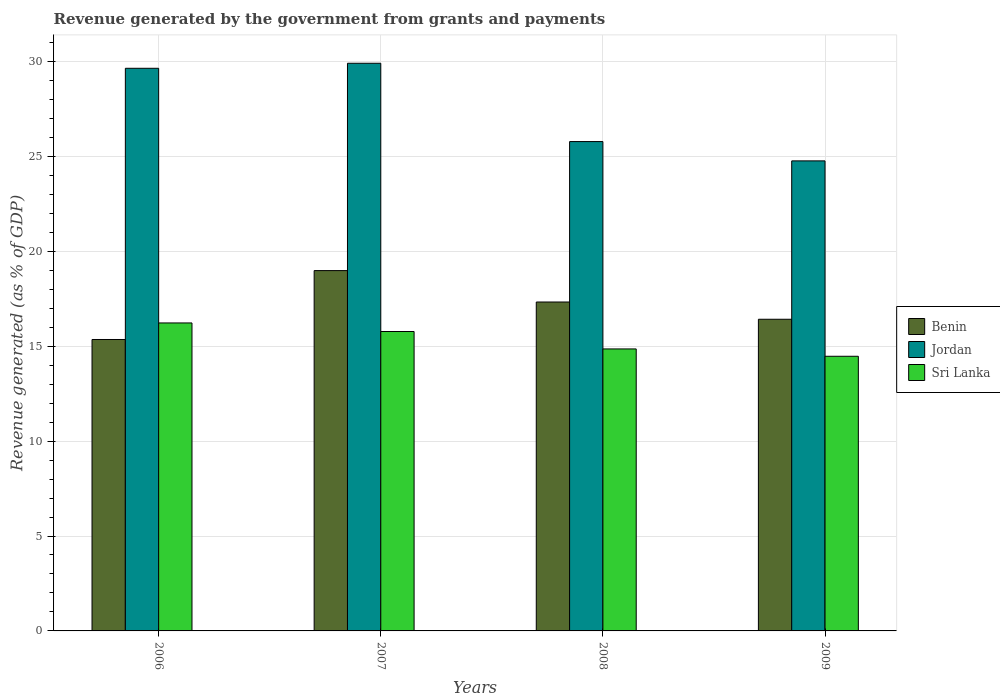Are the number of bars per tick equal to the number of legend labels?
Offer a very short reply. Yes. How many bars are there on the 1st tick from the left?
Give a very brief answer. 3. How many bars are there on the 4th tick from the right?
Your response must be concise. 3. What is the revenue generated by the government in Benin in 2006?
Make the answer very short. 15.35. Across all years, what is the maximum revenue generated by the government in Jordan?
Ensure brevity in your answer.  29.91. Across all years, what is the minimum revenue generated by the government in Sri Lanka?
Give a very brief answer. 14.47. In which year was the revenue generated by the government in Sri Lanka maximum?
Your answer should be compact. 2006. In which year was the revenue generated by the government in Sri Lanka minimum?
Offer a terse response. 2009. What is the total revenue generated by the government in Jordan in the graph?
Offer a terse response. 110.09. What is the difference between the revenue generated by the government in Sri Lanka in 2007 and that in 2008?
Ensure brevity in your answer.  0.92. What is the difference between the revenue generated by the government in Sri Lanka in 2008 and the revenue generated by the government in Jordan in 2009?
Give a very brief answer. -9.91. What is the average revenue generated by the government in Sri Lanka per year?
Provide a short and direct response. 15.33. In the year 2008, what is the difference between the revenue generated by the government in Benin and revenue generated by the government in Sri Lanka?
Make the answer very short. 2.47. In how many years, is the revenue generated by the government in Jordan greater than 12 %?
Provide a succinct answer. 4. What is the ratio of the revenue generated by the government in Sri Lanka in 2006 to that in 2008?
Keep it short and to the point. 1.09. What is the difference between the highest and the second highest revenue generated by the government in Benin?
Offer a terse response. 1.66. What is the difference between the highest and the lowest revenue generated by the government in Benin?
Give a very brief answer. 3.63. In how many years, is the revenue generated by the government in Benin greater than the average revenue generated by the government in Benin taken over all years?
Provide a short and direct response. 2. What does the 3rd bar from the left in 2009 represents?
Offer a very short reply. Sri Lanka. What does the 2nd bar from the right in 2006 represents?
Your response must be concise. Jordan. Is it the case that in every year, the sum of the revenue generated by the government in Benin and revenue generated by the government in Jordan is greater than the revenue generated by the government in Sri Lanka?
Provide a short and direct response. Yes. How many bars are there?
Your answer should be very brief. 12. What is the difference between two consecutive major ticks on the Y-axis?
Offer a very short reply. 5. What is the title of the graph?
Your answer should be compact. Revenue generated by the government from grants and payments. Does "Turkmenistan" appear as one of the legend labels in the graph?
Provide a short and direct response. No. What is the label or title of the Y-axis?
Offer a terse response. Revenue generated (as % of GDP). What is the Revenue generated (as % of GDP) in Benin in 2006?
Ensure brevity in your answer.  15.35. What is the Revenue generated (as % of GDP) of Jordan in 2006?
Your answer should be very brief. 29.64. What is the Revenue generated (as % of GDP) in Sri Lanka in 2006?
Your response must be concise. 16.23. What is the Revenue generated (as % of GDP) in Benin in 2007?
Offer a terse response. 18.98. What is the Revenue generated (as % of GDP) of Jordan in 2007?
Make the answer very short. 29.91. What is the Revenue generated (as % of GDP) in Sri Lanka in 2007?
Make the answer very short. 15.77. What is the Revenue generated (as % of GDP) in Benin in 2008?
Offer a terse response. 17.33. What is the Revenue generated (as % of GDP) of Jordan in 2008?
Offer a terse response. 25.78. What is the Revenue generated (as % of GDP) of Sri Lanka in 2008?
Your answer should be compact. 14.86. What is the Revenue generated (as % of GDP) in Benin in 2009?
Your answer should be compact. 16.42. What is the Revenue generated (as % of GDP) of Jordan in 2009?
Keep it short and to the point. 24.76. What is the Revenue generated (as % of GDP) of Sri Lanka in 2009?
Provide a short and direct response. 14.47. Across all years, what is the maximum Revenue generated (as % of GDP) of Benin?
Your response must be concise. 18.98. Across all years, what is the maximum Revenue generated (as % of GDP) of Jordan?
Your answer should be very brief. 29.91. Across all years, what is the maximum Revenue generated (as % of GDP) in Sri Lanka?
Offer a terse response. 16.23. Across all years, what is the minimum Revenue generated (as % of GDP) in Benin?
Make the answer very short. 15.35. Across all years, what is the minimum Revenue generated (as % of GDP) of Jordan?
Provide a succinct answer. 24.76. Across all years, what is the minimum Revenue generated (as % of GDP) in Sri Lanka?
Offer a very short reply. 14.47. What is the total Revenue generated (as % of GDP) of Benin in the graph?
Make the answer very short. 68.08. What is the total Revenue generated (as % of GDP) in Jordan in the graph?
Your response must be concise. 110.09. What is the total Revenue generated (as % of GDP) in Sri Lanka in the graph?
Offer a very short reply. 61.33. What is the difference between the Revenue generated (as % of GDP) in Benin in 2006 and that in 2007?
Offer a very short reply. -3.63. What is the difference between the Revenue generated (as % of GDP) in Jordan in 2006 and that in 2007?
Provide a short and direct response. -0.26. What is the difference between the Revenue generated (as % of GDP) in Sri Lanka in 2006 and that in 2007?
Ensure brevity in your answer.  0.45. What is the difference between the Revenue generated (as % of GDP) of Benin in 2006 and that in 2008?
Provide a short and direct response. -1.97. What is the difference between the Revenue generated (as % of GDP) of Jordan in 2006 and that in 2008?
Give a very brief answer. 3.86. What is the difference between the Revenue generated (as % of GDP) in Sri Lanka in 2006 and that in 2008?
Offer a terse response. 1.37. What is the difference between the Revenue generated (as % of GDP) in Benin in 2006 and that in 2009?
Your answer should be compact. -1.07. What is the difference between the Revenue generated (as % of GDP) in Jordan in 2006 and that in 2009?
Give a very brief answer. 4.88. What is the difference between the Revenue generated (as % of GDP) in Sri Lanka in 2006 and that in 2009?
Ensure brevity in your answer.  1.76. What is the difference between the Revenue generated (as % of GDP) in Benin in 2007 and that in 2008?
Your response must be concise. 1.66. What is the difference between the Revenue generated (as % of GDP) of Jordan in 2007 and that in 2008?
Provide a succinct answer. 4.13. What is the difference between the Revenue generated (as % of GDP) of Sri Lanka in 2007 and that in 2008?
Provide a succinct answer. 0.92. What is the difference between the Revenue generated (as % of GDP) in Benin in 2007 and that in 2009?
Provide a short and direct response. 2.56. What is the difference between the Revenue generated (as % of GDP) in Jordan in 2007 and that in 2009?
Your response must be concise. 5.14. What is the difference between the Revenue generated (as % of GDP) of Sri Lanka in 2007 and that in 2009?
Offer a terse response. 1.3. What is the difference between the Revenue generated (as % of GDP) of Benin in 2008 and that in 2009?
Provide a succinct answer. 0.91. What is the difference between the Revenue generated (as % of GDP) of Sri Lanka in 2008 and that in 2009?
Your answer should be very brief. 0.39. What is the difference between the Revenue generated (as % of GDP) of Benin in 2006 and the Revenue generated (as % of GDP) of Jordan in 2007?
Your answer should be very brief. -14.55. What is the difference between the Revenue generated (as % of GDP) of Benin in 2006 and the Revenue generated (as % of GDP) of Sri Lanka in 2007?
Your response must be concise. -0.42. What is the difference between the Revenue generated (as % of GDP) of Jordan in 2006 and the Revenue generated (as % of GDP) of Sri Lanka in 2007?
Provide a short and direct response. 13.87. What is the difference between the Revenue generated (as % of GDP) in Benin in 2006 and the Revenue generated (as % of GDP) in Jordan in 2008?
Keep it short and to the point. -10.43. What is the difference between the Revenue generated (as % of GDP) of Benin in 2006 and the Revenue generated (as % of GDP) of Sri Lanka in 2008?
Keep it short and to the point. 0.5. What is the difference between the Revenue generated (as % of GDP) in Jordan in 2006 and the Revenue generated (as % of GDP) in Sri Lanka in 2008?
Provide a short and direct response. 14.79. What is the difference between the Revenue generated (as % of GDP) in Benin in 2006 and the Revenue generated (as % of GDP) in Jordan in 2009?
Your answer should be very brief. -9.41. What is the difference between the Revenue generated (as % of GDP) of Benin in 2006 and the Revenue generated (as % of GDP) of Sri Lanka in 2009?
Your answer should be compact. 0.88. What is the difference between the Revenue generated (as % of GDP) of Jordan in 2006 and the Revenue generated (as % of GDP) of Sri Lanka in 2009?
Offer a very short reply. 15.17. What is the difference between the Revenue generated (as % of GDP) of Benin in 2007 and the Revenue generated (as % of GDP) of Jordan in 2008?
Give a very brief answer. -6.8. What is the difference between the Revenue generated (as % of GDP) in Benin in 2007 and the Revenue generated (as % of GDP) in Sri Lanka in 2008?
Your answer should be very brief. 4.13. What is the difference between the Revenue generated (as % of GDP) in Jordan in 2007 and the Revenue generated (as % of GDP) in Sri Lanka in 2008?
Keep it short and to the point. 15.05. What is the difference between the Revenue generated (as % of GDP) of Benin in 2007 and the Revenue generated (as % of GDP) of Jordan in 2009?
Provide a succinct answer. -5.78. What is the difference between the Revenue generated (as % of GDP) of Benin in 2007 and the Revenue generated (as % of GDP) of Sri Lanka in 2009?
Ensure brevity in your answer.  4.51. What is the difference between the Revenue generated (as % of GDP) of Jordan in 2007 and the Revenue generated (as % of GDP) of Sri Lanka in 2009?
Give a very brief answer. 15.44. What is the difference between the Revenue generated (as % of GDP) in Benin in 2008 and the Revenue generated (as % of GDP) in Jordan in 2009?
Offer a very short reply. -7.44. What is the difference between the Revenue generated (as % of GDP) of Benin in 2008 and the Revenue generated (as % of GDP) of Sri Lanka in 2009?
Your answer should be very brief. 2.86. What is the difference between the Revenue generated (as % of GDP) in Jordan in 2008 and the Revenue generated (as % of GDP) in Sri Lanka in 2009?
Make the answer very short. 11.31. What is the average Revenue generated (as % of GDP) of Benin per year?
Provide a short and direct response. 17.02. What is the average Revenue generated (as % of GDP) in Jordan per year?
Your answer should be very brief. 27.52. What is the average Revenue generated (as % of GDP) in Sri Lanka per year?
Make the answer very short. 15.33. In the year 2006, what is the difference between the Revenue generated (as % of GDP) in Benin and Revenue generated (as % of GDP) in Jordan?
Ensure brevity in your answer.  -14.29. In the year 2006, what is the difference between the Revenue generated (as % of GDP) of Benin and Revenue generated (as % of GDP) of Sri Lanka?
Provide a succinct answer. -0.87. In the year 2006, what is the difference between the Revenue generated (as % of GDP) in Jordan and Revenue generated (as % of GDP) in Sri Lanka?
Make the answer very short. 13.42. In the year 2007, what is the difference between the Revenue generated (as % of GDP) of Benin and Revenue generated (as % of GDP) of Jordan?
Provide a short and direct response. -10.92. In the year 2007, what is the difference between the Revenue generated (as % of GDP) of Benin and Revenue generated (as % of GDP) of Sri Lanka?
Your answer should be very brief. 3.21. In the year 2007, what is the difference between the Revenue generated (as % of GDP) in Jordan and Revenue generated (as % of GDP) in Sri Lanka?
Give a very brief answer. 14.13. In the year 2008, what is the difference between the Revenue generated (as % of GDP) of Benin and Revenue generated (as % of GDP) of Jordan?
Your response must be concise. -8.45. In the year 2008, what is the difference between the Revenue generated (as % of GDP) in Benin and Revenue generated (as % of GDP) in Sri Lanka?
Give a very brief answer. 2.47. In the year 2008, what is the difference between the Revenue generated (as % of GDP) in Jordan and Revenue generated (as % of GDP) in Sri Lanka?
Provide a short and direct response. 10.92. In the year 2009, what is the difference between the Revenue generated (as % of GDP) in Benin and Revenue generated (as % of GDP) in Jordan?
Make the answer very short. -8.34. In the year 2009, what is the difference between the Revenue generated (as % of GDP) in Benin and Revenue generated (as % of GDP) in Sri Lanka?
Your answer should be very brief. 1.95. In the year 2009, what is the difference between the Revenue generated (as % of GDP) in Jordan and Revenue generated (as % of GDP) in Sri Lanka?
Your answer should be compact. 10.29. What is the ratio of the Revenue generated (as % of GDP) of Benin in 2006 to that in 2007?
Give a very brief answer. 0.81. What is the ratio of the Revenue generated (as % of GDP) in Jordan in 2006 to that in 2007?
Your answer should be compact. 0.99. What is the ratio of the Revenue generated (as % of GDP) of Sri Lanka in 2006 to that in 2007?
Keep it short and to the point. 1.03. What is the ratio of the Revenue generated (as % of GDP) in Benin in 2006 to that in 2008?
Offer a terse response. 0.89. What is the ratio of the Revenue generated (as % of GDP) of Jordan in 2006 to that in 2008?
Offer a very short reply. 1.15. What is the ratio of the Revenue generated (as % of GDP) in Sri Lanka in 2006 to that in 2008?
Provide a succinct answer. 1.09. What is the ratio of the Revenue generated (as % of GDP) in Benin in 2006 to that in 2009?
Your answer should be very brief. 0.94. What is the ratio of the Revenue generated (as % of GDP) in Jordan in 2006 to that in 2009?
Give a very brief answer. 1.2. What is the ratio of the Revenue generated (as % of GDP) of Sri Lanka in 2006 to that in 2009?
Make the answer very short. 1.12. What is the ratio of the Revenue generated (as % of GDP) in Benin in 2007 to that in 2008?
Provide a short and direct response. 1.1. What is the ratio of the Revenue generated (as % of GDP) of Jordan in 2007 to that in 2008?
Keep it short and to the point. 1.16. What is the ratio of the Revenue generated (as % of GDP) of Sri Lanka in 2007 to that in 2008?
Make the answer very short. 1.06. What is the ratio of the Revenue generated (as % of GDP) in Benin in 2007 to that in 2009?
Ensure brevity in your answer.  1.16. What is the ratio of the Revenue generated (as % of GDP) of Jordan in 2007 to that in 2009?
Your answer should be very brief. 1.21. What is the ratio of the Revenue generated (as % of GDP) in Sri Lanka in 2007 to that in 2009?
Provide a short and direct response. 1.09. What is the ratio of the Revenue generated (as % of GDP) of Benin in 2008 to that in 2009?
Ensure brevity in your answer.  1.06. What is the ratio of the Revenue generated (as % of GDP) of Jordan in 2008 to that in 2009?
Keep it short and to the point. 1.04. What is the ratio of the Revenue generated (as % of GDP) in Sri Lanka in 2008 to that in 2009?
Provide a short and direct response. 1.03. What is the difference between the highest and the second highest Revenue generated (as % of GDP) of Benin?
Ensure brevity in your answer.  1.66. What is the difference between the highest and the second highest Revenue generated (as % of GDP) of Jordan?
Offer a very short reply. 0.26. What is the difference between the highest and the second highest Revenue generated (as % of GDP) of Sri Lanka?
Your answer should be very brief. 0.45. What is the difference between the highest and the lowest Revenue generated (as % of GDP) of Benin?
Offer a very short reply. 3.63. What is the difference between the highest and the lowest Revenue generated (as % of GDP) in Jordan?
Your answer should be very brief. 5.14. What is the difference between the highest and the lowest Revenue generated (as % of GDP) of Sri Lanka?
Ensure brevity in your answer.  1.76. 